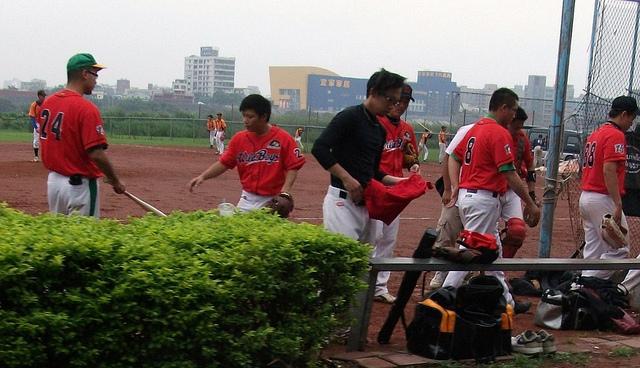What sport is this?
Write a very short answer. Baseball. What color is the team's shirt?
Short answer required. Red. Is it a metal bench?
Quick response, please. Yes. What color is the hat on the man holding a bat?
Concise answer only. Green. 